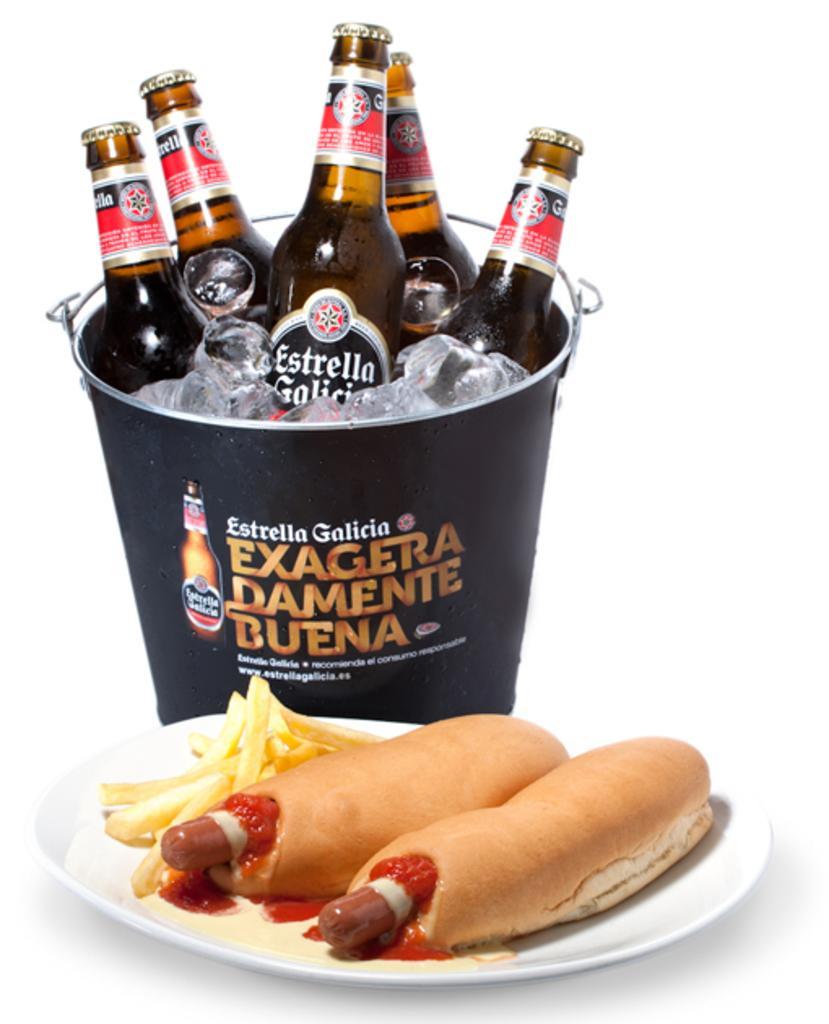In one or two sentences, can you explain what this image depicts? In this image, there is a plate contains some food and there is a bucket behind this plate. This bucket contains ice cubes and bottles. 